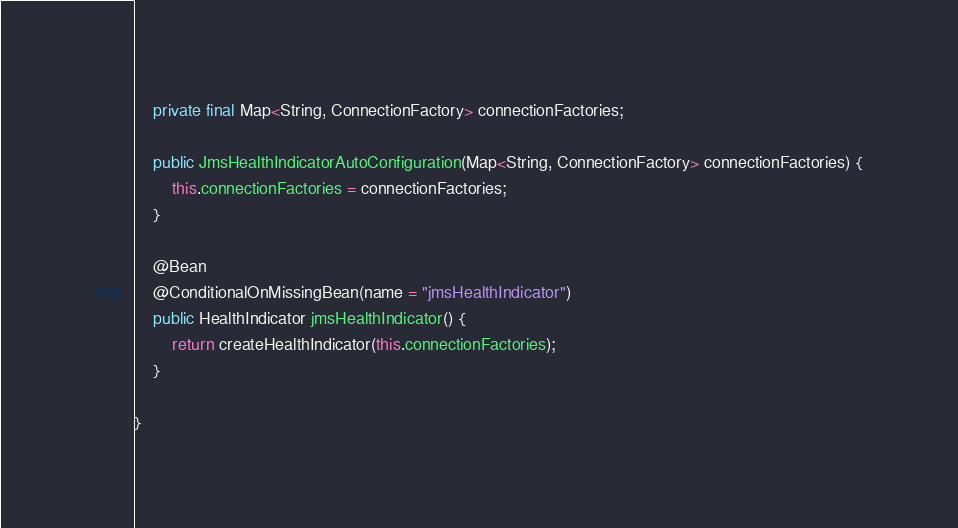<code> <loc_0><loc_0><loc_500><loc_500><_Java_>	private final Map<String, ConnectionFactory> connectionFactories;

	public JmsHealthIndicatorAutoConfiguration(Map<String, ConnectionFactory> connectionFactories) {
		this.connectionFactories = connectionFactories;
	}

	@Bean
	@ConditionalOnMissingBean(name = "jmsHealthIndicator")
	public HealthIndicator jmsHealthIndicator() {
		return createHealthIndicator(this.connectionFactories);
	}

}
</code> 